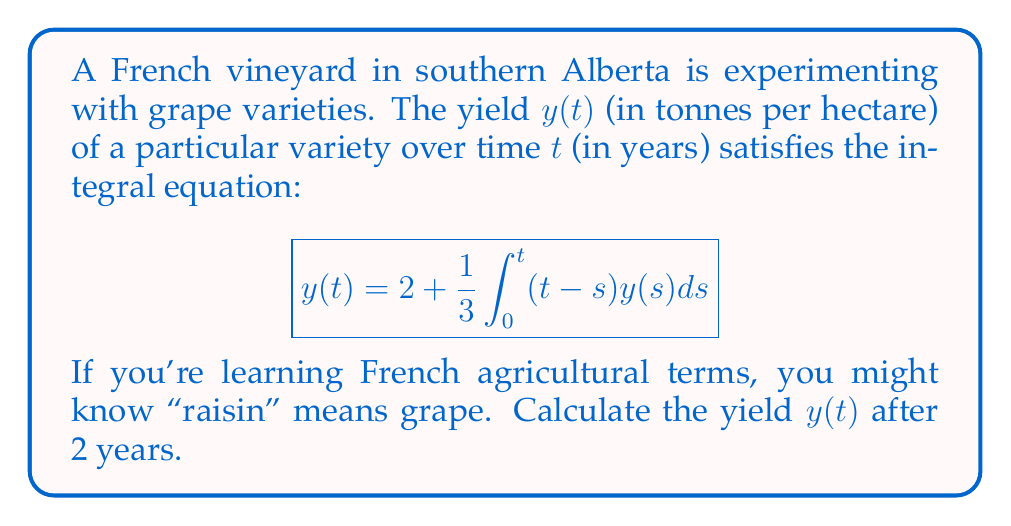Solve this math problem. To solve this integral equation, we can use the method of successive approximations:

1) Start with the initial approximation $y_0(t) = 2$

2) Substitute this into the right-hand side of the equation:
   $$y_1(t) = 2 + \frac{1}{3}\int_0^t (t-s)2ds = 2 + \frac{2}{3}\int_0^t (t-s)ds$$

3) Evaluate the integral:
   $$y_1(t) = 2 + \frac{2}{3}[ts - \frac{s^2}{2}]_0^t = 2 + \frac{2}{3}(t^2 - \frac{t^2}{2}) = 2 + \frac{t^2}{3}$$

4) Now use $y_1(t)$ to find $y_2(t)$:
   $$y_2(t) = 2 + \frac{1}{3}\int_0^t (t-s)(2 + \frac{s^2}{3})ds$$

5) Expand and integrate:
   $$y_2(t) = 2 + \frac{2}{3}\int_0^t (t-s)ds + \frac{1}{9}\int_0^t (t-s)s^2ds$$
   $$= 2 + \frac{t^2}{3} + \frac{1}{9}[ts^3 - \frac{s^4}{4}]_0^t$$
   $$= 2 + \frac{t^2}{3} + \frac{t^4}{36}$$

6) The process converges quickly, and $y_2(t)$ is a good approximation of the true solution.

7) To find the yield after 2 years, substitute $t=2$ into $y_2(t)$:
   $$y_2(2) = 2 + \frac{2^2}{3} + \frac{2^4}{36} = 2 + \frac{4}{3} + \frac{16}{36} = 2 + \frac{4}{3} + \frac{4}{9} = \frac{18}{9} + \frac{12}{9} + \frac{4}{9} = \frac{34}{9}$$

Therefore, the yield after 2 years is approximately $\frac{34}{9}$ tonnes per hectare.
Answer: $\frac{34}{9}$ tonnes/hectare 